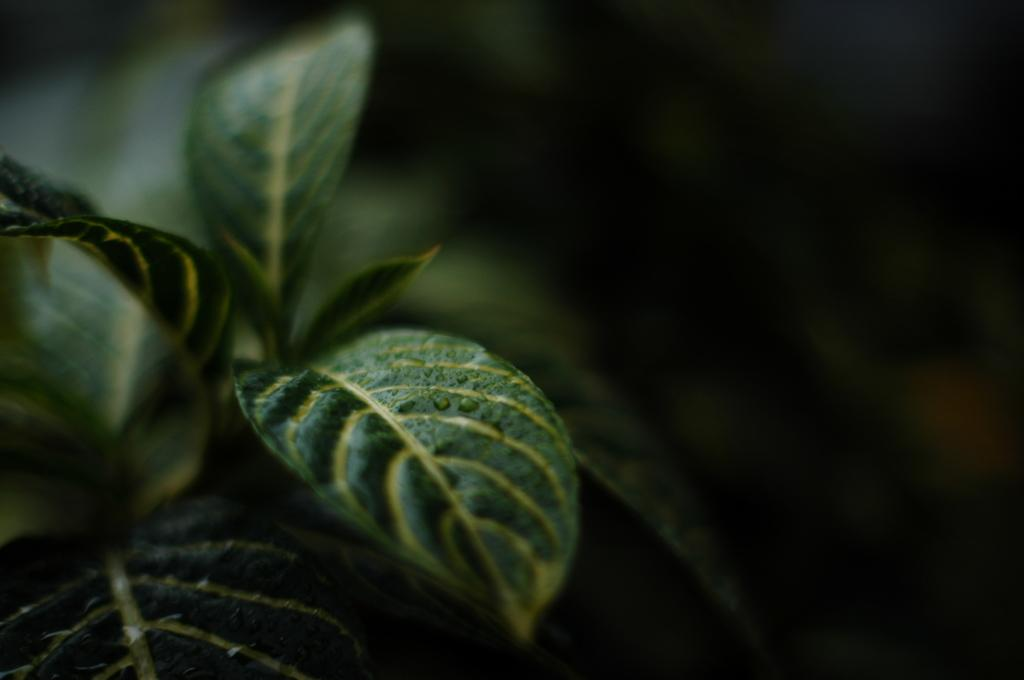What is the main subject of the picture? The main subject of the picture is a plant. What color are the leaves of the plant? The plant has green leaves. Can you describe the background of the image? The background of the image is blurred. How would you describe the overall lighting in the image? The image is dark. How many tomatoes can be seen growing on the plant in the image? There are no tomatoes visible in the image; it only shows a plant with green leaves. Can you tell me how many dogs are helping the plant grow in the image? There are no dogs present in the image, and the plant does not require any assistance to grow. 